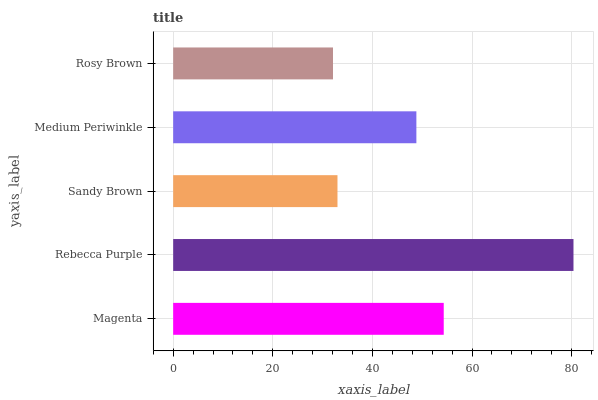Is Rosy Brown the minimum?
Answer yes or no. Yes. Is Rebecca Purple the maximum?
Answer yes or no. Yes. Is Sandy Brown the minimum?
Answer yes or no. No. Is Sandy Brown the maximum?
Answer yes or no. No. Is Rebecca Purple greater than Sandy Brown?
Answer yes or no. Yes. Is Sandy Brown less than Rebecca Purple?
Answer yes or no. Yes. Is Sandy Brown greater than Rebecca Purple?
Answer yes or no. No. Is Rebecca Purple less than Sandy Brown?
Answer yes or no. No. Is Medium Periwinkle the high median?
Answer yes or no. Yes. Is Medium Periwinkle the low median?
Answer yes or no. Yes. Is Rebecca Purple the high median?
Answer yes or no. No. Is Rosy Brown the low median?
Answer yes or no. No. 